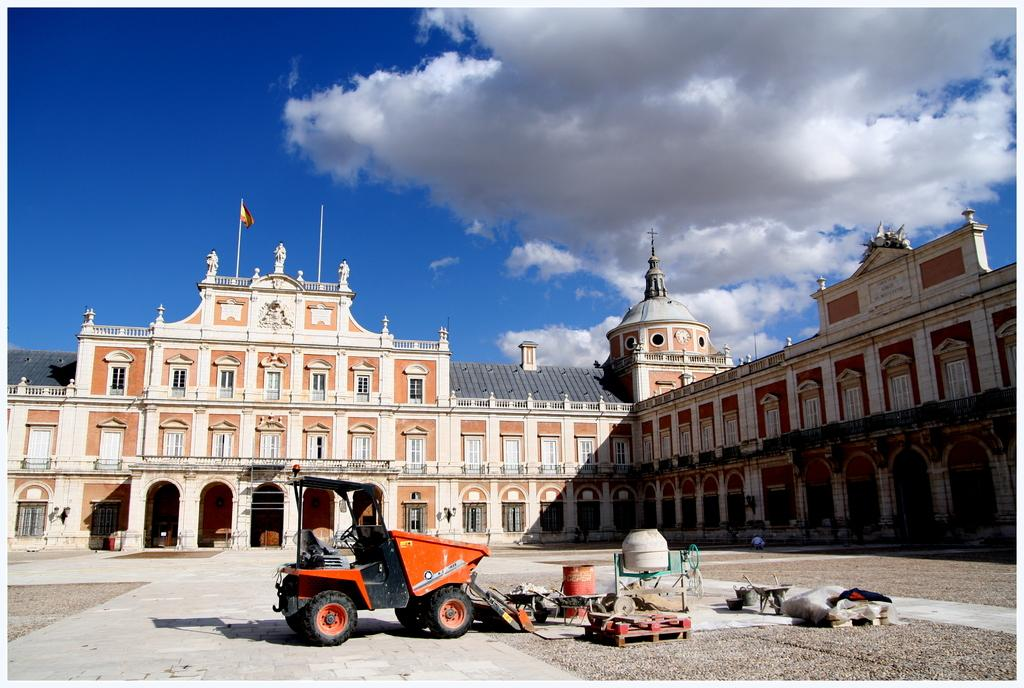What is the main subject in the center of the picture? There is a building in the center of the picture. What can be seen in the foreground of the picture? There are vehicles and other construction materials in the foreground of the picture. How would you describe the weather in the image? The sky is sunny, which suggests good weather. What does the dad's stomach feel like in the image? There is no dad or stomach present in the image. 